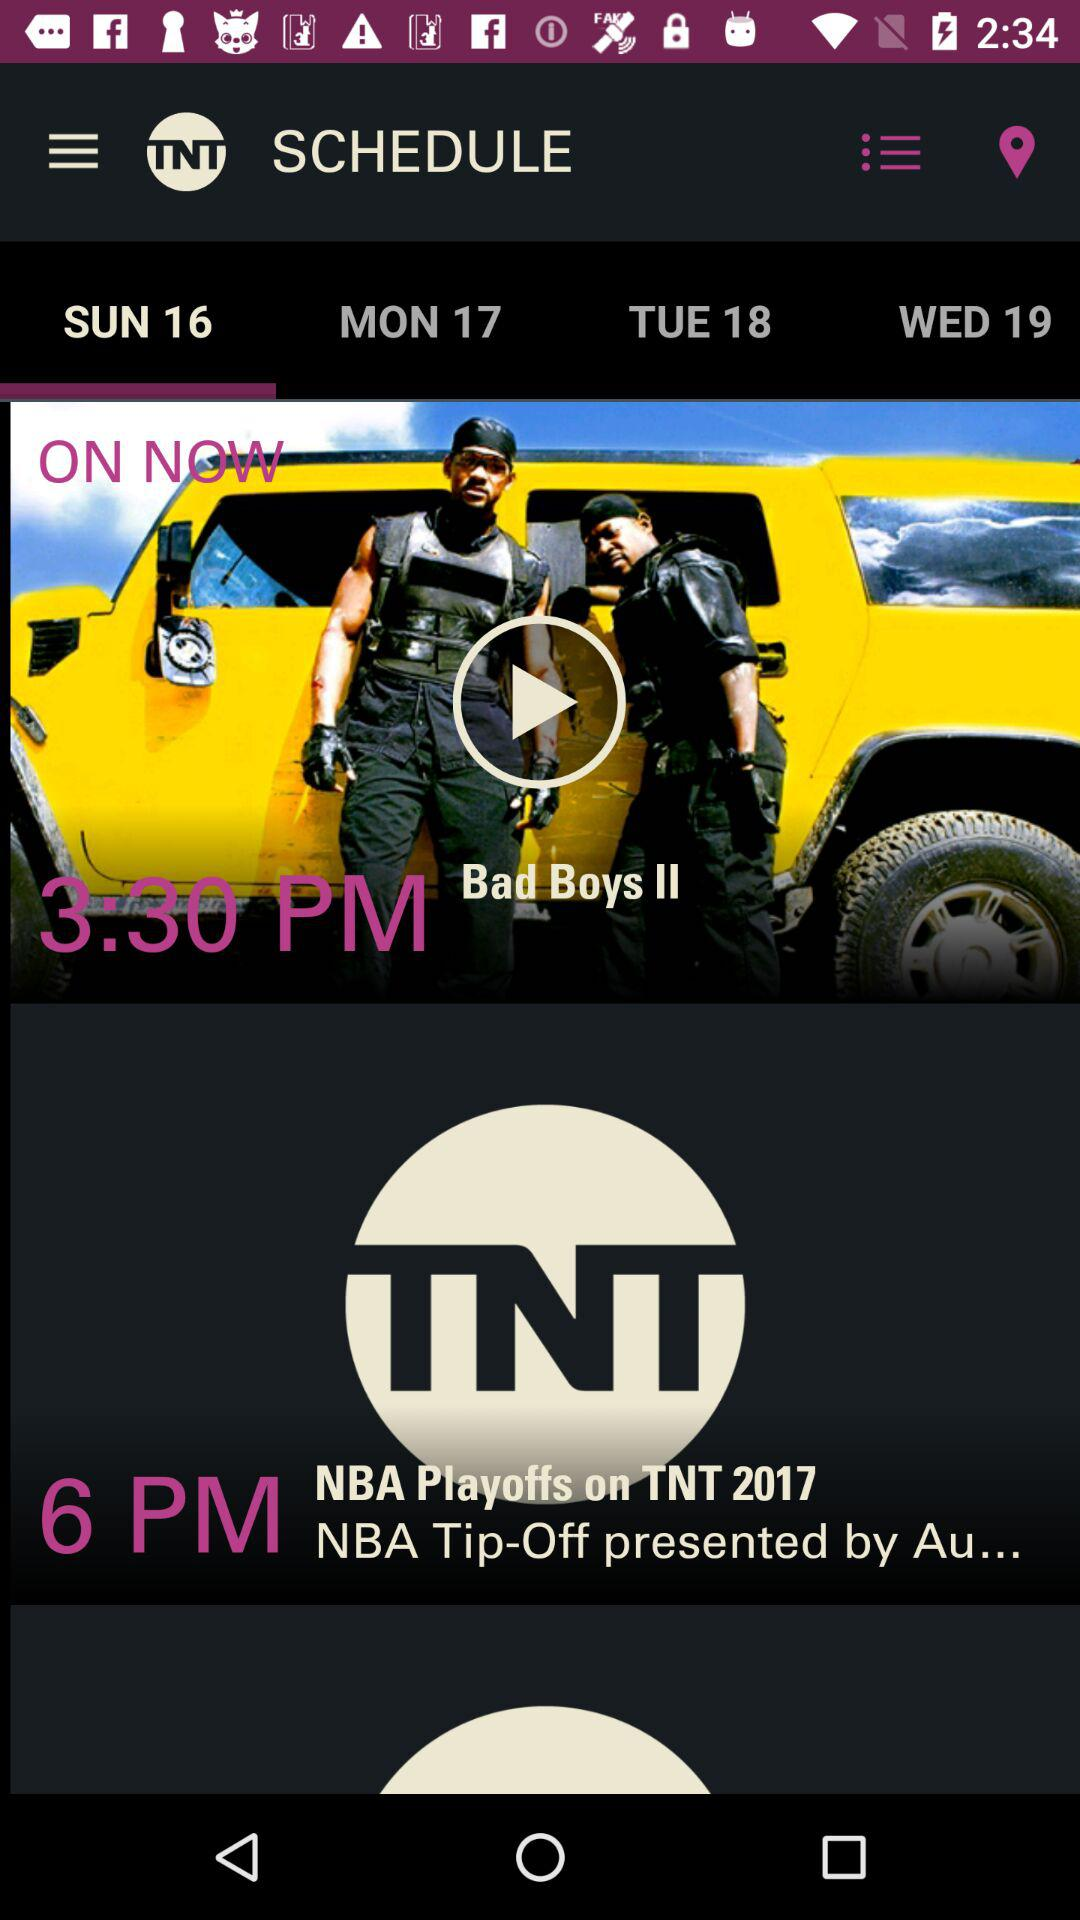Which tab is selected? The selected tab is "SUN 16". 